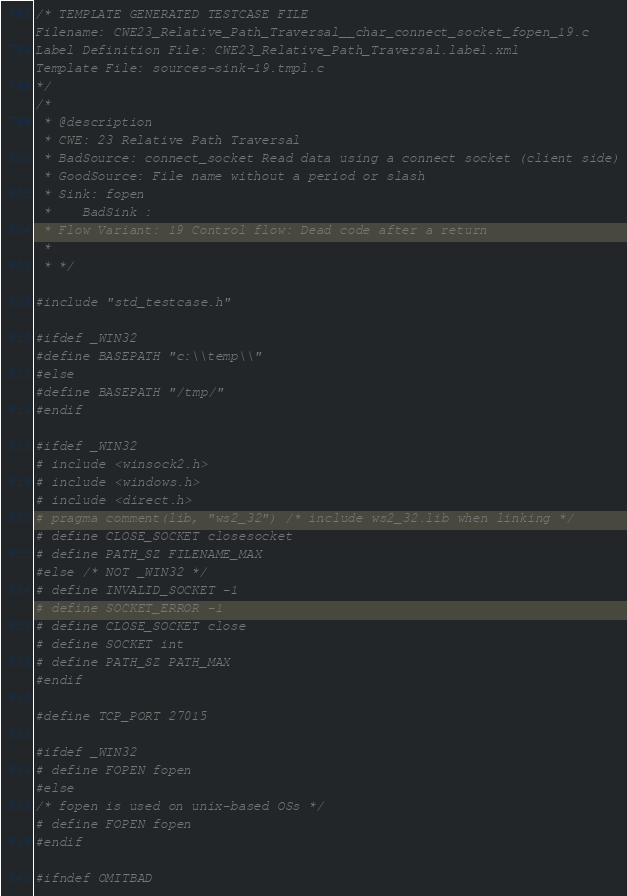Convert code to text. <code><loc_0><loc_0><loc_500><loc_500><_C_>/* TEMPLATE GENERATED TESTCASE FILE
Filename: CWE23_Relative_Path_Traversal__char_connect_socket_fopen_19.c
Label Definition File: CWE23_Relative_Path_Traversal.label.xml
Template File: sources-sink-19.tmpl.c
*/
/*
 * @description
 * CWE: 23 Relative Path Traversal
 * BadSource: connect_socket Read data using a connect socket (client side)
 * GoodSource: File name without a period or slash
 * Sink: fopen
 *    BadSink :
 * Flow Variant: 19 Control flow: Dead code after a return
 *
 * */

#include "std_testcase.h"

#ifdef _WIN32
#define BASEPATH "c:\\temp\\"
#else
#define BASEPATH "/tmp/"
#endif

#ifdef _WIN32
# include <winsock2.h>
# include <windows.h>
# include <direct.h>
# pragma comment(lib, "ws2_32") /* include ws2_32.lib when linking */
# define CLOSE_SOCKET closesocket
# define PATH_SZ FILENAME_MAX
#else /* NOT _WIN32 */
# define INVALID_SOCKET -1
# define SOCKET_ERROR -1
# define CLOSE_SOCKET close
# define SOCKET int
# define PATH_SZ PATH_MAX
#endif

#define TCP_PORT 27015

#ifdef _WIN32
# define FOPEN fopen
#else
/* fopen is used on unix-based OSs */
# define FOPEN fopen
#endif

#ifndef OMITBAD
</code> 